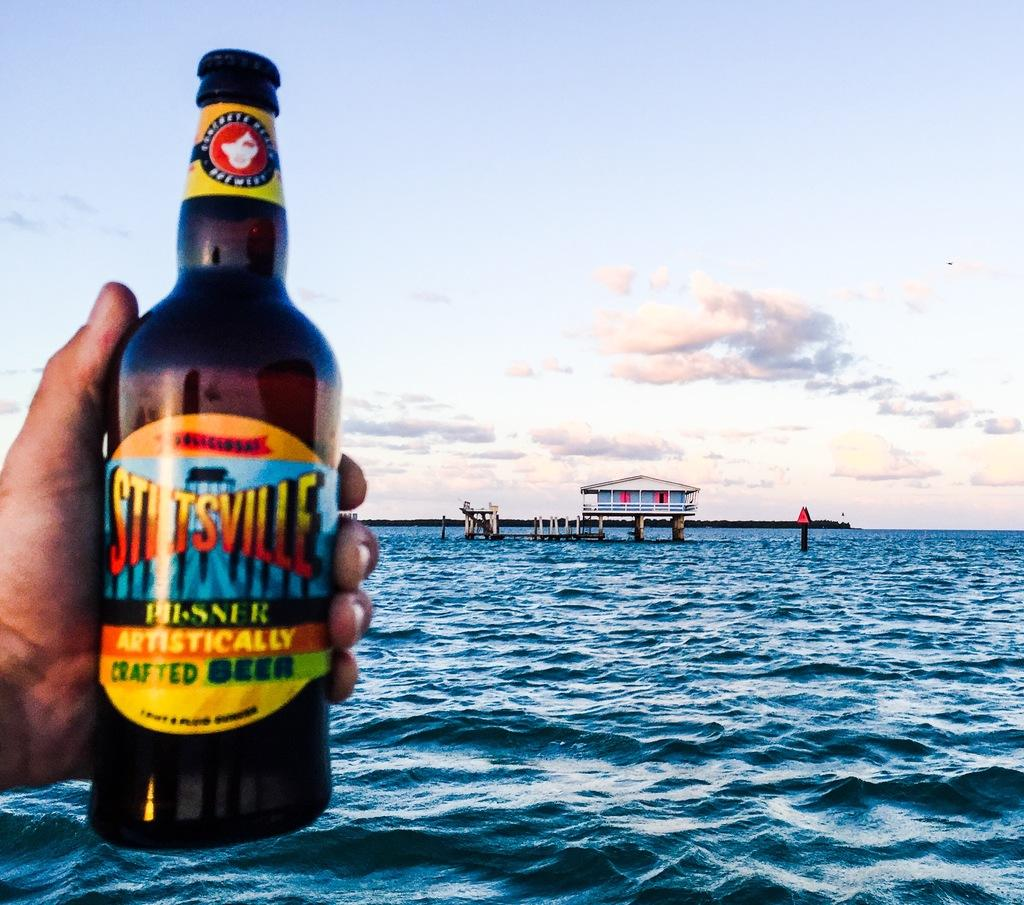<image>
Describe the image concisely. An ad showing a bottle of Stitsville crafted beer being held by someone with the sea in the background. 